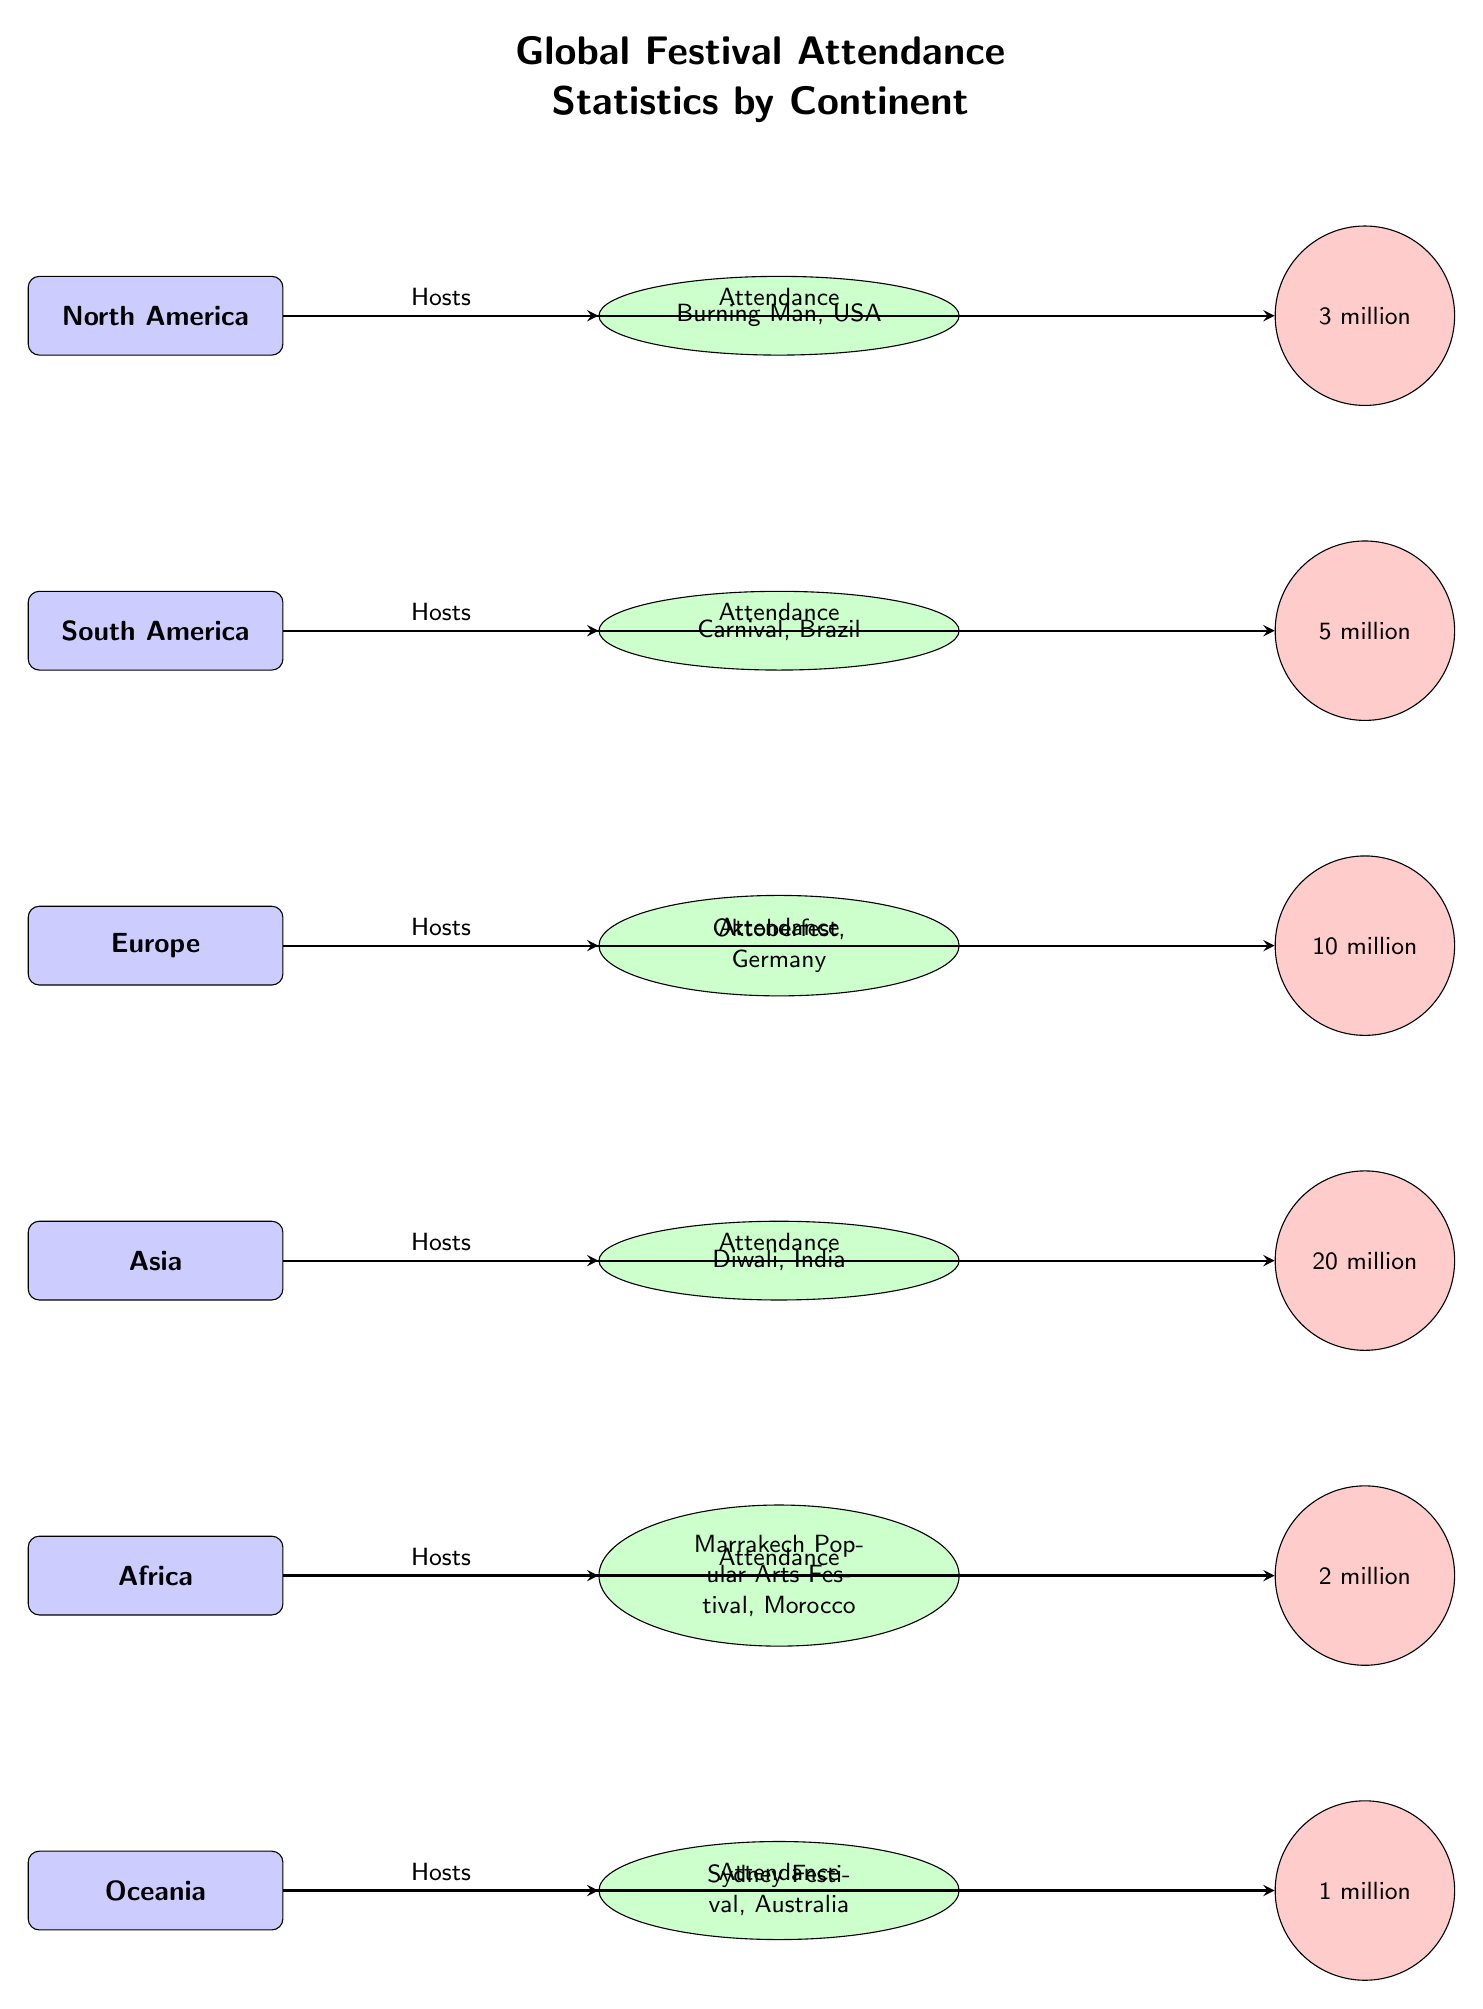What festival is hosted in North America? The diagram clearly indicates that the festival hosted in North America is Burning Man, as it is connected directly to the North America node.
Answer: Burning Man What is the attendance for Oktoberfest in Germany? The diagram shows an attendance node connected to the Oktoberfest festival node, indicating that the attendance is 10 million.
Answer: 10 million How many continents are represented in the diagram? By counting the continent nodes in the diagram, there are six continents represented: North America, South America, Europe, Asia, Africa, and Oceania.
Answer: 6 Which festival has the highest attendance? By comparing the attendance values connected to each festival node, Diwali in India has the highest attendance at 20 million.
Answer: 20 million What is the attendance for the Sydney Festival in Australia? The diagram shows that the Sydney Festival has an attendance node attached, which indicates the attendance is 1 million.
Answer: 1 million Which continent hosts the Marrakech Popular Arts Festival? The diagram connects the Marrakech Popular Arts Festival directly to the Africa continent node, indicating that Africa is the host continent.
Answer: Africa What is the total attendance of festivals hosted in South America and Oceania combined? The attendance for Carnival in South America is 5 million and for the Sydney Festival in Oceania is 1 million. Adding these gives a total of 6 million.
Answer: 6 million What type of diagram is used here? The structure of the diagram with nodes and arrows indicating relationships suggests it is a Textbook Diagram for displaying statistics and connections between different entities.
Answer: Textbook Diagram 